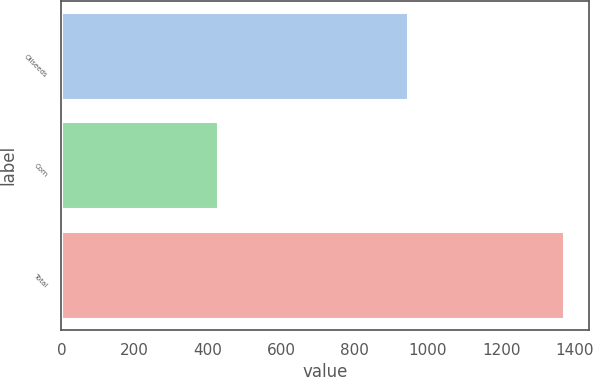Convert chart to OTSL. <chart><loc_0><loc_0><loc_500><loc_500><bar_chart><fcel>Oilseeds<fcel>Corn<fcel>Total<nl><fcel>945<fcel>427<fcel>1372<nl></chart> 